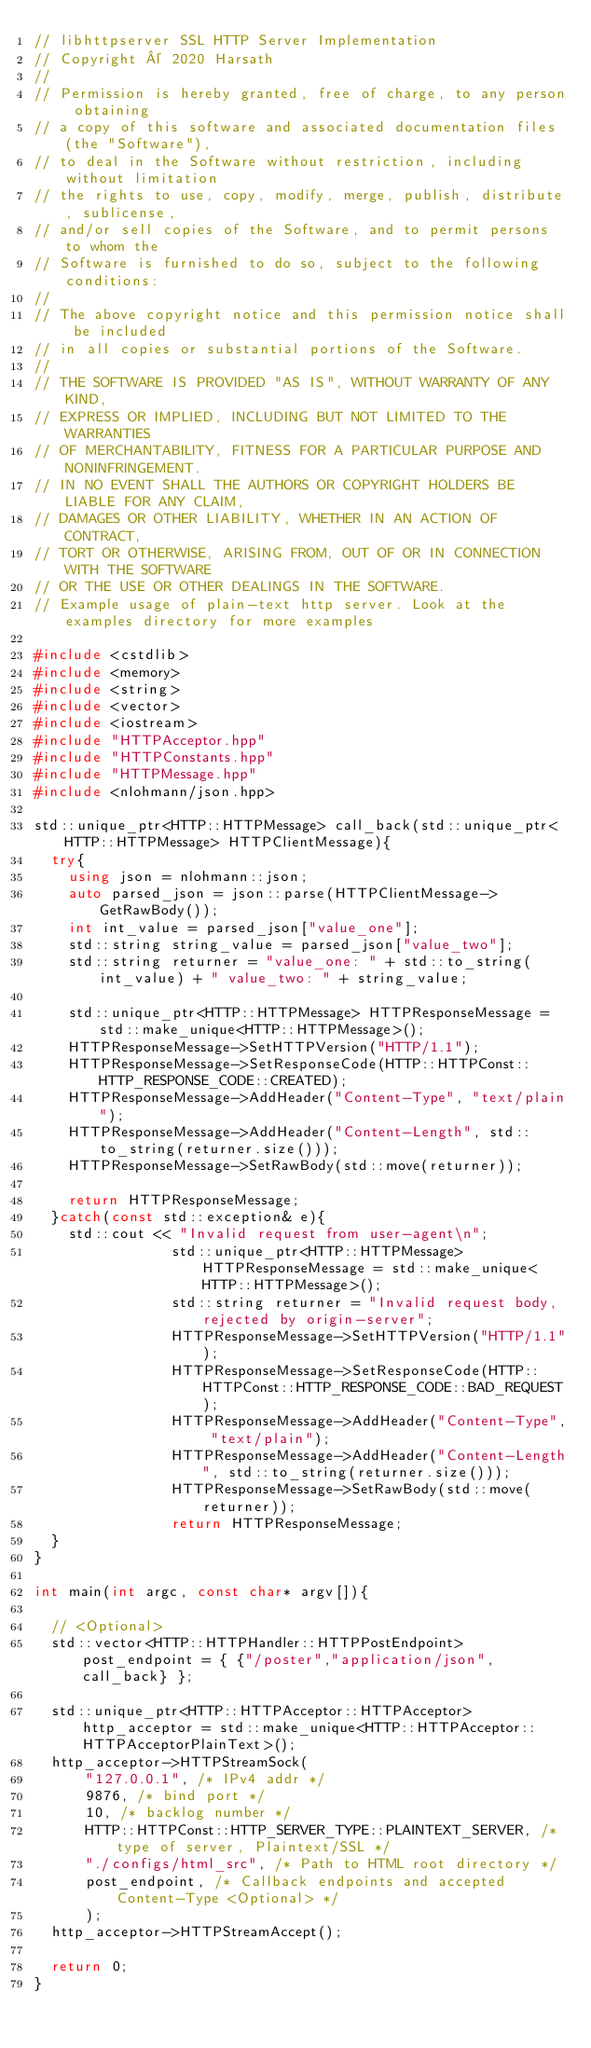<code> <loc_0><loc_0><loc_500><loc_500><_C++_>// libhttpserver SSL HTTP Server Implementation
// Copyright © 2020 Harsath
//
// Permission is hereby granted, free of charge, to any person obtaining
// a copy of this software and associated documentation files (the "Software"),
// to deal in the Software without restriction, including without limitation
// the rights to use, copy, modify, merge, publish, distribute, sublicense,
// and/or sell copies of the Software, and to permit persons to whom the
// Software is furnished to do so, subject to the following conditions:
//
// The above copyright notice and this permission notice shall be included
// in all copies or substantial portions of the Software.
//
// THE SOFTWARE IS PROVIDED "AS IS", WITHOUT WARRANTY OF ANY KIND,
// EXPRESS OR IMPLIED, INCLUDING BUT NOT LIMITED TO THE WARRANTIES
// OF MERCHANTABILITY, FITNESS FOR A PARTICULAR PURPOSE AND NONINFRINGEMENT.
// IN NO EVENT SHALL THE AUTHORS OR COPYRIGHT HOLDERS BE LIABLE FOR ANY CLAIM,
// DAMAGES OR OTHER LIABILITY, WHETHER IN AN ACTION OF CONTRACT,
// TORT OR OTHERWISE, ARISING FROM, OUT OF OR IN CONNECTION WITH THE SOFTWARE
// OR THE USE OR OTHER DEALINGS IN THE SOFTWARE.
// Example usage of plain-text http server. Look at the examples directory for more examples

#include <cstdlib>
#include <memory>
#include <string>
#include <vector>
#include <iostream>
#include "HTTPAcceptor.hpp"
#include "HTTPConstants.hpp"
#include "HTTPMessage.hpp"
#include <nlohmann/json.hpp>

std::unique_ptr<HTTP::HTTPMessage> call_back(std::unique_ptr<HTTP::HTTPMessage> HTTPClientMessage){
	try{
		using json = nlohmann::json;
		auto parsed_json = json::parse(HTTPClientMessage->GetRawBody());
		int int_value = parsed_json["value_one"];
		std::string string_value = parsed_json["value_two"];
		std::string returner = "value_one: " + std::to_string(int_value) + " value_two: " + string_value;

		std::unique_ptr<HTTP::HTTPMessage> HTTPResponseMessage = std::make_unique<HTTP::HTTPMessage>();
		HTTPResponseMessage->SetHTTPVersion("HTTP/1.1");
		HTTPResponseMessage->SetResponseCode(HTTP::HTTPConst::HTTP_RESPONSE_CODE::CREATED);
		HTTPResponseMessage->AddHeader("Content-Type", "text/plain");
		HTTPResponseMessage->AddHeader("Content-Length", std::to_string(returner.size()));
		HTTPResponseMessage->SetRawBody(std::move(returner));

		return HTTPResponseMessage;
	}catch(const std::exception& e){
		std::cout << "Invalid request from user-agent\n";
                std::unique_ptr<HTTP::HTTPMessage> HTTPResponseMessage = std::make_unique<HTTP::HTTPMessage>();
                std::string returner = "Invalid request body, rejected by origin-server";
                HTTPResponseMessage->SetHTTPVersion("HTTP/1.1");
                HTTPResponseMessage->SetResponseCode(HTTP::HTTPConst::HTTP_RESPONSE_CODE::BAD_REQUEST);
                HTTPResponseMessage->AddHeader("Content-Type", "text/plain");
                HTTPResponseMessage->AddHeader("Content-Length", std::to_string(returner.size()));
                HTTPResponseMessage->SetRawBody(std::move(returner));
                return HTTPResponseMessage;
	}
}

int main(int argc, const char* argv[]){

	// <Optional>
	std::vector<HTTP::HTTPHandler::HTTPPostEndpoint> post_endpoint = { {"/poster","application/json", call_back} };

	std::unique_ptr<HTTP::HTTPAcceptor::HTTPAcceptor> http_acceptor = std::make_unique<HTTP::HTTPAcceptor::HTTPAcceptorPlainText>();
	http_acceptor->HTTPStreamSock(
			"127.0.0.1", /* IPv4 addr */
			9876, /* bind port */
			10, /* backlog number */
			HTTP::HTTPConst::HTTP_SERVER_TYPE::PLAINTEXT_SERVER, /* type of server, Plaintext/SSL */
			"./configs/html_src", /* Path to HTML root directory */
			post_endpoint, /* Callback endpoints and accepted Content-Type <Optional> */
			);
	http_acceptor->HTTPStreamAccept();

	return 0;
}
</code> 